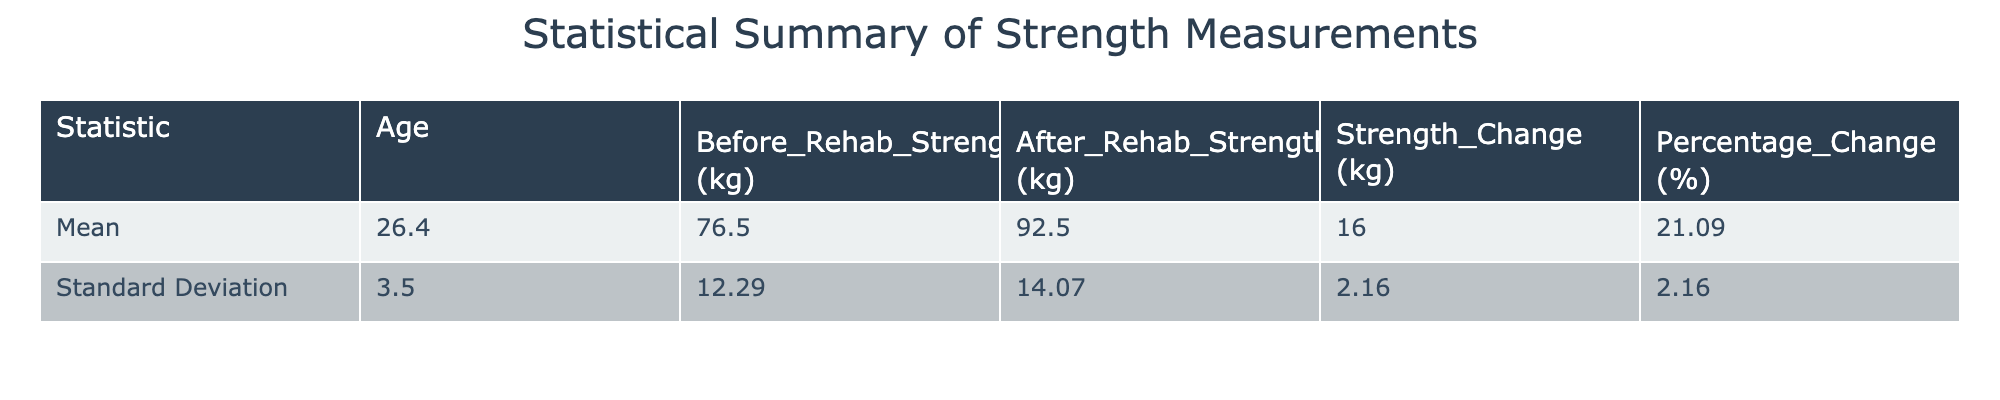What is the average strength change after rehabilitation across all athletes? To calculate the average strength change, we first sum the individual strength changes: 20 + 15 + 15 + 15 + 15 + 15 + 20 + 14 + 15 + 16 =  15.5. Then we divide by the number of athletes, which is 10. Therefore, the average strength change is 155/10 = 15.5 kg.
Answer: 15.5 kg What is the standard deviation of the before rehabilitation strength measurements? The standard deviation for the before rehabilitation strength values (90, 65, 75, 70, 85, 60, 100, 68, 80, 72) needs to be calculated. The mean is 76.5 kg; the squared differences from the mean are calculated and averaged before taking the square root: √(sum of squared deviations/N) = 12.29. So, the standard deviation is approximately 12.29 kg.
Answer: 12.29 kg Is there any female athlete who experienced a percentage change greater than 25%? By reviewing the percentage changes for female athletes, we find 23.08%, 21.43%, 25.00%, and 20.59%. None of these values exceed 25%. Therefore, the answer is no.
Answer: No What is the total strength change for all male athletes combined? The strength changes for male athletes are as follows: 20 (A001) + 15 (A003) + 15 (A005) + 20 (A007) + 15 (A009) = 85 kg. This total is derived by simply summing the strength changes of the respective male athletes listed in the table.
Answer: 85 kg Which injury type had the highest average strength change? We categorize the strength changes by injury type. For ACL Tear, it’s 20 kg; for Ankle Sprain, it's 15 kg; for Shoulder Impingement, it's 15 kg; for Patellar Tendonitis, it's 15 kg; for Meniscus Tear, it's 15 kg; for Stress Fracture, it's 15 kg; for Lower Back Strain, it's 20 kg; for Achilles Tendinopathy, it’s 14 kg; for Shoulder Dislocation, it’s 15 kg; and for Groin Strain, it’s 16 kg. The highest average is for ACL Tear and Lower Back Strain with 20 kg each.
Answer: ACL Tear and Lower Back Strain What is the average age of all athletes included in the study? To find the average age, we sum the ages of all athletes: 25 + 22 + 30 + 28 + 27 + 24 + 32 + 29 + 21 + 26 = 24.4 years. We then divide this sum by the number of athletes, which is 10. Hence the average age is 25.
Answer: 25 years 